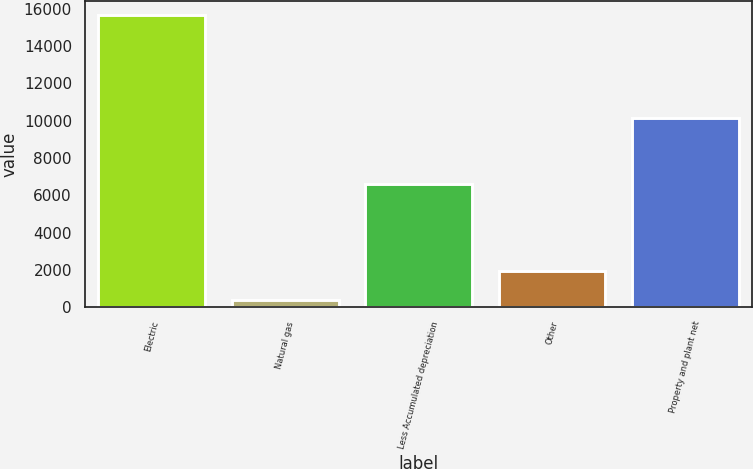<chart> <loc_0><loc_0><loc_500><loc_500><bar_chart><fcel>Electric<fcel>Natural gas<fcel>Less Accumulated depreciation<fcel>Other<fcel>Property and plant net<nl><fcel>15638<fcel>393<fcel>6614<fcel>1917.5<fcel>10161<nl></chart> 